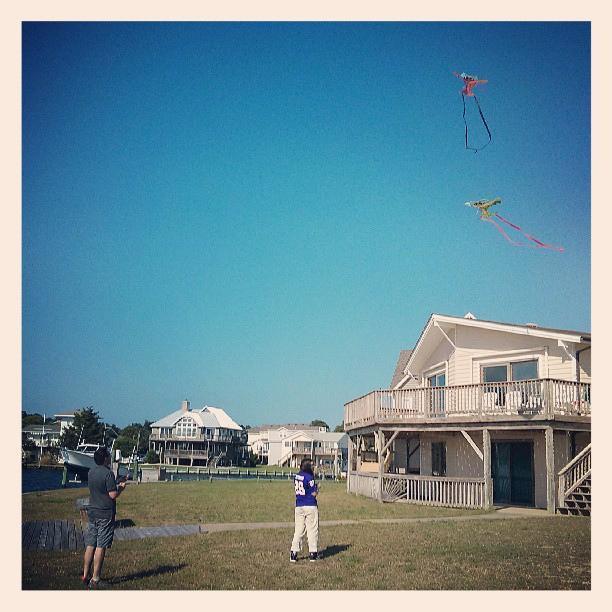How many tails does the kite have?
Give a very brief answer. 2. How many birds do you see in the air?
Give a very brief answer. 0. How many buildings are there?
Give a very brief answer. 4. How many people in the photo?
Give a very brief answer. 2. How many people are there?
Give a very brief answer. 2. How many baby sheep are there?
Give a very brief answer. 0. 